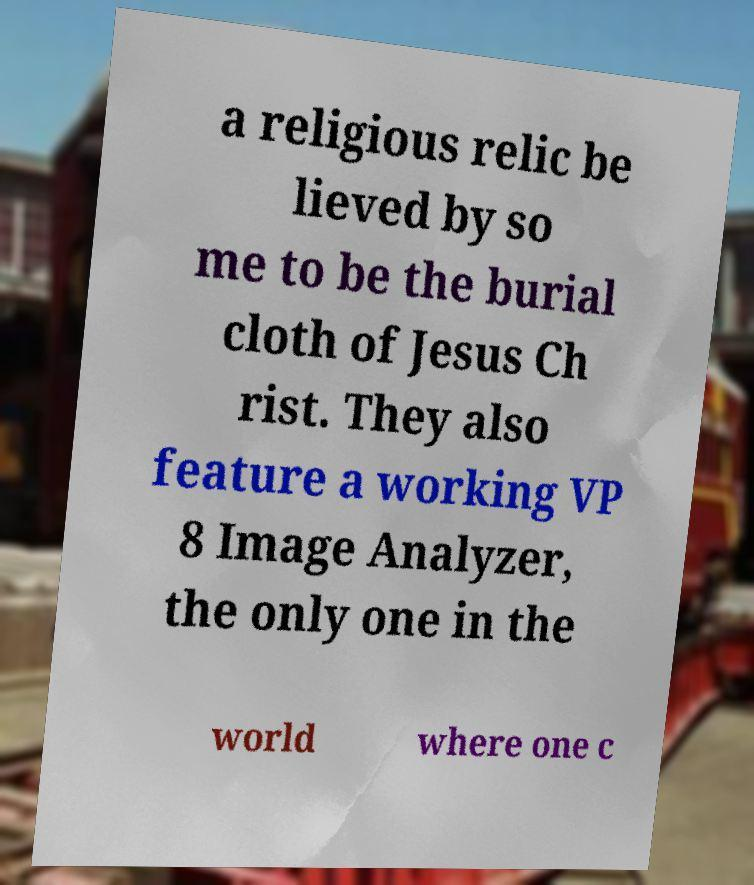Can you read and provide the text displayed in the image?This photo seems to have some interesting text. Can you extract and type it out for me? a religious relic be lieved by so me to be the burial cloth of Jesus Ch rist. They also feature a working VP 8 Image Analyzer, the only one in the world where one c 